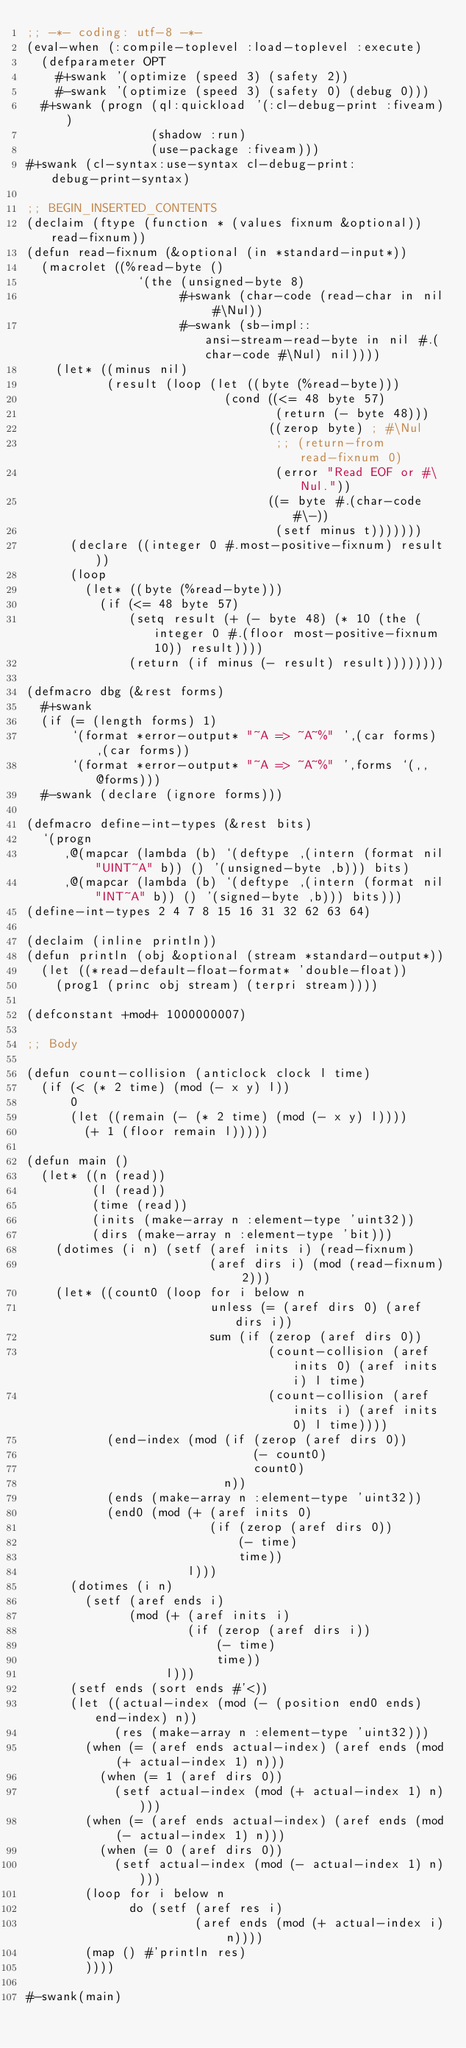Convert code to text. <code><loc_0><loc_0><loc_500><loc_500><_Lisp_>;; -*- coding: utf-8 -*-
(eval-when (:compile-toplevel :load-toplevel :execute)
  (defparameter OPT
    #+swank '(optimize (speed 3) (safety 2))
    #-swank '(optimize (speed 3) (safety 0) (debug 0)))
  #+swank (progn (ql:quickload '(:cl-debug-print :fiveam))
                 (shadow :run)
                 (use-package :fiveam)))
#+swank (cl-syntax:use-syntax cl-debug-print:debug-print-syntax)

;; BEGIN_INSERTED_CONTENTS
(declaim (ftype (function * (values fixnum &optional)) read-fixnum))
(defun read-fixnum (&optional (in *standard-input*))
  (macrolet ((%read-byte ()
               `(the (unsigned-byte 8)
                     #+swank (char-code (read-char in nil #\Nul))
                     #-swank (sb-impl::ansi-stream-read-byte in nil #.(char-code #\Nul) nil))))
    (let* ((minus nil)
           (result (loop (let ((byte (%read-byte)))
                           (cond ((<= 48 byte 57)
                                  (return (- byte 48)))
                                 ((zerop byte) ; #\Nul
                                  ;; (return-from read-fixnum 0)
                                  (error "Read EOF or #\Nul."))
                                 ((= byte #.(char-code #\-))
                                  (setf minus t)))))))
      (declare ((integer 0 #.most-positive-fixnum) result))
      (loop
        (let* ((byte (%read-byte)))
          (if (<= 48 byte 57)
              (setq result (+ (- byte 48) (* 10 (the (integer 0 #.(floor most-positive-fixnum 10)) result))))
              (return (if minus (- result) result))))))))

(defmacro dbg (&rest forms)
  #+swank
  (if (= (length forms) 1)
      `(format *error-output* "~A => ~A~%" ',(car forms) ,(car forms))
      `(format *error-output* "~A => ~A~%" ',forms `(,,@forms)))
  #-swank (declare (ignore forms)))

(defmacro define-int-types (&rest bits)
  `(progn
     ,@(mapcar (lambda (b) `(deftype ,(intern (format nil "UINT~A" b)) () '(unsigned-byte ,b))) bits)
     ,@(mapcar (lambda (b) `(deftype ,(intern (format nil "INT~A" b)) () '(signed-byte ,b))) bits)))
(define-int-types 2 4 7 8 15 16 31 32 62 63 64)

(declaim (inline println))
(defun println (obj &optional (stream *standard-output*))
  (let ((*read-default-float-format* 'double-float))
    (prog1 (princ obj stream) (terpri stream))))

(defconstant +mod+ 1000000007)

;; Body

(defun count-collision (anticlock clock l time)
  (if (< (* 2 time) (mod (- x y) l))
      0
      (let ((remain (- (* 2 time) (mod (- x y) l))))
        (+ 1 (floor remain l)))))

(defun main ()
  (let* ((n (read))
         (l (read))
         (time (read))
         (inits (make-array n :element-type 'uint32))
         (dirs (make-array n :element-type 'bit)))
    (dotimes (i n) (setf (aref inits i) (read-fixnum)
                         (aref dirs i) (mod (read-fixnum) 2)))
    (let* ((count0 (loop for i below n
                         unless (= (aref dirs 0) (aref dirs i))
                         sum (if (zerop (aref dirs 0))
                                 (count-collision (aref inits 0) (aref inits i) l time)
                                 (count-collision (aref inits i) (aref inits 0) l time))))
           (end-index (mod (if (zerop (aref dirs 0))
                               (- count0)
                               count0)
                           n))
           (ends (make-array n :element-type 'uint32))
           (end0 (mod (+ (aref inits 0)
                         (if (zerop (aref dirs 0))
                             (- time)
                             time))
                      l)))
      (dotimes (i n)
        (setf (aref ends i)
              (mod (+ (aref inits i)
                      (if (zerop (aref dirs i))
                          (- time)
                          time))
                   l)))
      (setf ends (sort ends #'<))
      (let ((actual-index (mod (- (position end0 ends) end-index) n))
            (res (make-array n :element-type 'uint32)))
        (when (= (aref ends actual-index) (aref ends (mod (+ actual-index 1) n)))
          (when (= 1 (aref dirs 0))
            (setf actual-index (mod (+ actual-index 1) n))))
        (when (= (aref ends actual-index) (aref ends (mod (- actual-index 1) n)))
          (when (= 0 (aref dirs 0))
            (setf actual-index (mod (- actual-index 1) n))))
        (loop for i below n
              do (setf (aref res i)
                       (aref ends (mod (+ actual-index i) n))))
        (map () #'println res)
        ))))

#-swank(main)
</code> 